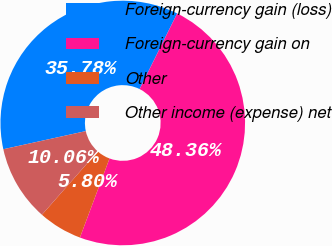<chart> <loc_0><loc_0><loc_500><loc_500><pie_chart><fcel>Foreign-currency gain (loss)<fcel>Foreign-currency gain on<fcel>Other<fcel>Other income (expense) net<nl><fcel>35.78%<fcel>48.36%<fcel>5.8%<fcel>10.06%<nl></chart> 